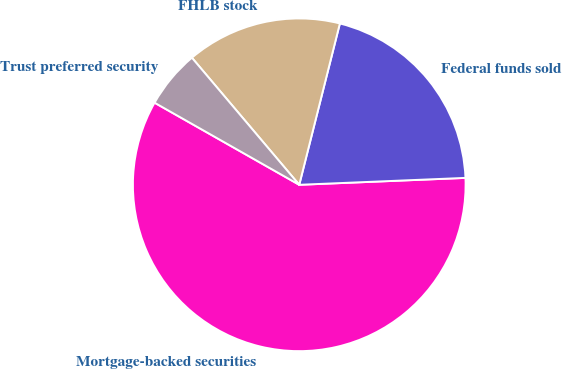Convert chart. <chart><loc_0><loc_0><loc_500><loc_500><pie_chart><fcel>Mortgage-backed securities<fcel>Federal funds sold<fcel>FHLB stock<fcel>Trust preferred security<nl><fcel>58.87%<fcel>20.41%<fcel>15.09%<fcel>5.62%<nl></chart> 